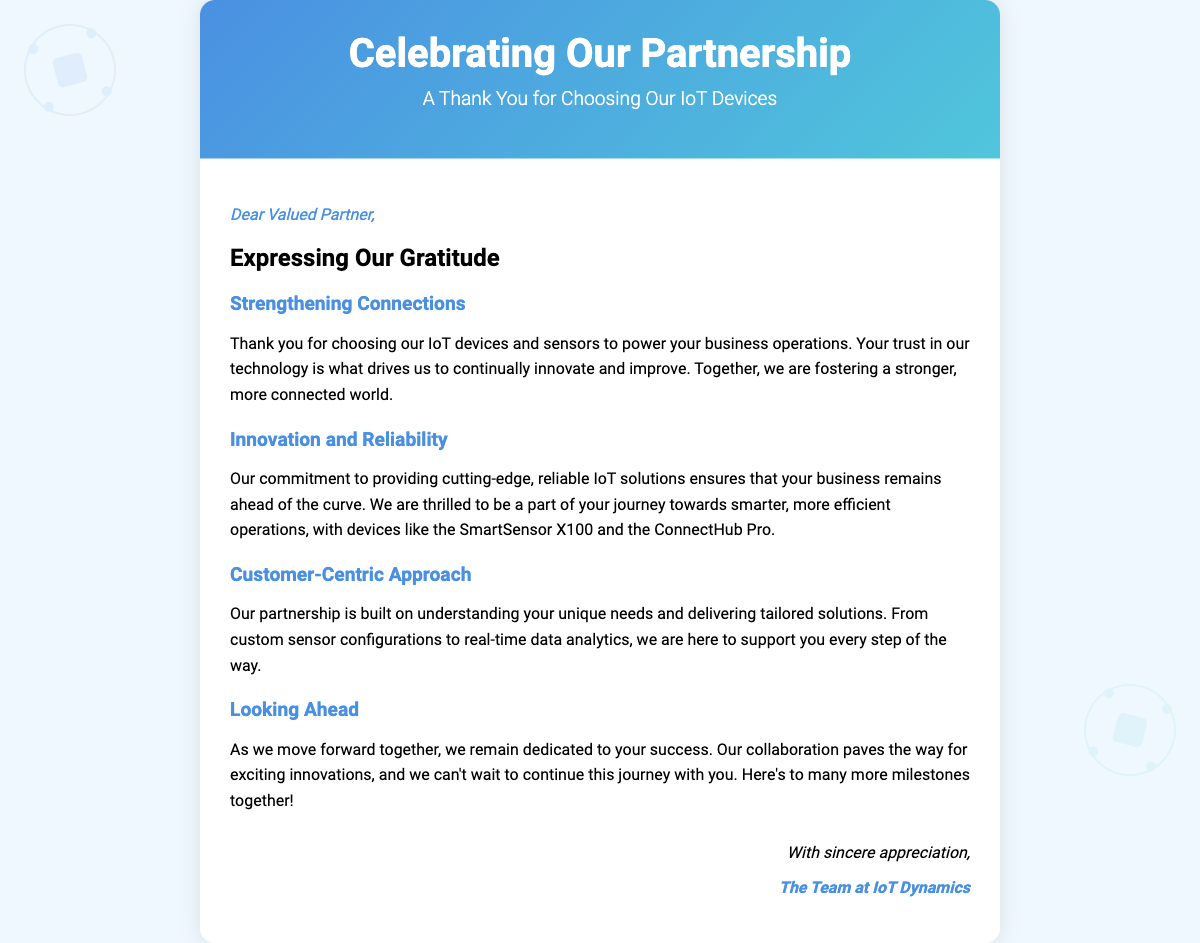What is the title of the card? The title of the card is prominently displayed at the top and reads "Celebrating Our Partnership."
Answer: Celebrating Our Partnership Who is the card addressed to? The card is addressed to a "Valued Partner" as mentioned in the greeting.
Answer: Valued Partner Which two IoT devices are specifically mentioned? The card lists two specific devices, "SmartSensor X100" and "ConnectHub Pro," under the innovation section.
Answer: SmartSensor X100, ConnectHub Pro What is the main theme of the card? The main theme of the card centers around expressing gratitude for the partnership and promoting collaboration through IoT solutions.
Answer: Gratitude for partnership What color gradient is used in the card header? The card header features a gradient that transitions from one color to another, specified as "blue" to "light blue."
Answer: Blue to light blue What is the closing statement of the card? The closing statement expresses appreciation and includes a signature from "The Team at IoT Dynamics."
Answer: With sincere appreciation In what section does the card talk about tailored solutions? The card discusses tailored solutions in the section entitled "Customer-Centric Approach."
Answer: Customer-Centric Approach What visual elements are included in the card design? The card design includes interconnected graphics of devices represented as circles and rectangles to symbolize IoT connectivity.
Answer: Interconnected graphics of devices 